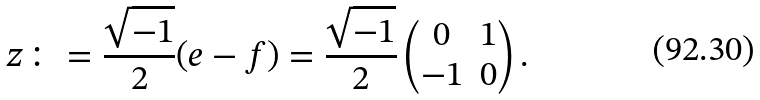Convert formula to latex. <formula><loc_0><loc_0><loc_500><loc_500>z \colon = \frac { \sqrt { - 1 } } 2 ( e - f ) = \frac { \sqrt { - 1 } } 2 \begin{pmatrix} 0 & 1 \\ - 1 & 0 \end{pmatrix} .</formula> 